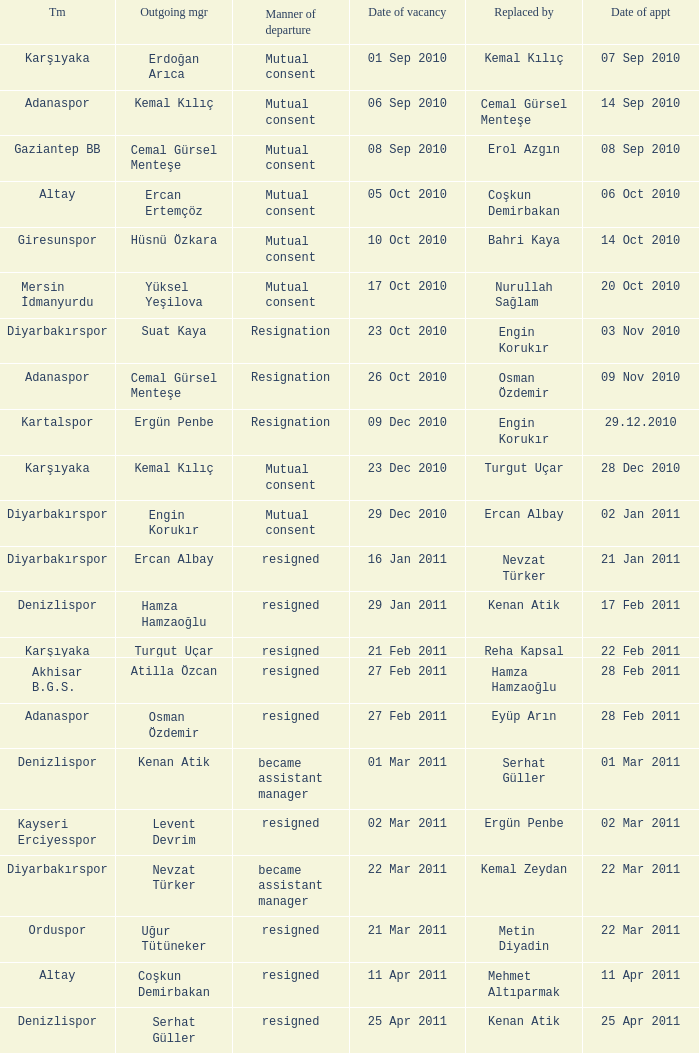Who replaced the outgoing manager Hüsnü Özkara?  Bahri Kaya. Can you give me this table as a dict? {'header': ['Tm', 'Outgoing mgr', 'Manner of departure', 'Date of vacancy', 'Replaced by', 'Date of appt'], 'rows': [['Karşıyaka', 'Erdoğan Arıca', 'Mutual consent', '01 Sep 2010', 'Kemal Kılıç', '07 Sep 2010'], ['Adanaspor', 'Kemal Kılıç', 'Mutual consent', '06 Sep 2010', 'Cemal Gürsel Menteşe', '14 Sep 2010'], ['Gaziantep BB', 'Cemal Gürsel Menteşe', 'Mutual consent', '08 Sep 2010', 'Erol Azgın', '08 Sep 2010'], ['Altay', 'Ercan Ertemçöz', 'Mutual consent', '05 Oct 2010', 'Coşkun Demirbakan', '06 Oct 2010'], ['Giresunspor', 'Hüsnü Özkara', 'Mutual consent', '10 Oct 2010', 'Bahri Kaya', '14 Oct 2010'], ['Mersin İdmanyurdu', 'Yüksel Yeşilova', 'Mutual consent', '17 Oct 2010', 'Nurullah Sağlam', '20 Oct 2010'], ['Diyarbakırspor', 'Suat Kaya', 'Resignation', '23 Oct 2010', 'Engin Korukır', '03 Nov 2010'], ['Adanaspor', 'Cemal Gürsel Menteşe', 'Resignation', '26 Oct 2010', 'Osman Özdemir', '09 Nov 2010'], ['Kartalspor', 'Ergün Penbe', 'Resignation', '09 Dec 2010', 'Engin Korukır', '29.12.2010'], ['Karşıyaka', 'Kemal Kılıç', 'Mutual consent', '23 Dec 2010', 'Turgut Uçar', '28 Dec 2010'], ['Diyarbakırspor', 'Engin Korukır', 'Mutual consent', '29 Dec 2010', 'Ercan Albay', '02 Jan 2011'], ['Diyarbakırspor', 'Ercan Albay', 'resigned', '16 Jan 2011', 'Nevzat Türker', '21 Jan 2011'], ['Denizlispor', 'Hamza Hamzaoğlu', 'resigned', '29 Jan 2011', 'Kenan Atik', '17 Feb 2011'], ['Karşıyaka', 'Turgut Uçar', 'resigned', '21 Feb 2011', 'Reha Kapsal', '22 Feb 2011'], ['Akhisar B.G.S.', 'Atilla Özcan', 'resigned', '27 Feb 2011', 'Hamza Hamzaoğlu', '28 Feb 2011'], ['Adanaspor', 'Osman Özdemir', 'resigned', '27 Feb 2011', 'Eyüp Arın', '28 Feb 2011'], ['Denizlispor', 'Kenan Atik', 'became assistant manager', '01 Mar 2011', 'Serhat Güller', '01 Mar 2011'], ['Kayseri Erciyesspor', 'Levent Devrim', 'resigned', '02 Mar 2011', 'Ergün Penbe', '02 Mar 2011'], ['Diyarbakırspor', 'Nevzat Türker', 'became assistant manager', '22 Mar 2011', 'Kemal Zeydan', '22 Mar 2011'], ['Orduspor', 'Uğur Tütüneker', 'resigned', '21 Mar 2011', 'Metin Diyadin', '22 Mar 2011'], ['Altay', 'Coşkun Demirbakan', 'resigned', '11 Apr 2011', 'Mehmet Altıparmak', '11 Apr 2011'], ['Denizlispor', 'Serhat Güller', 'resigned', '25 Apr 2011', 'Kenan Atik', '25 Apr 2011']]} 